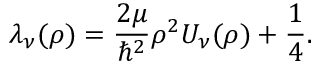Convert formula to latex. <formula><loc_0><loc_0><loc_500><loc_500>\lambda _ { \nu } ( \rho ) = \frac { 2 \mu } { \hbar { ^ } { 2 } } \rho ^ { 2 } U _ { \nu } ( \rho ) + \frac { 1 } { 4 } .</formula> 